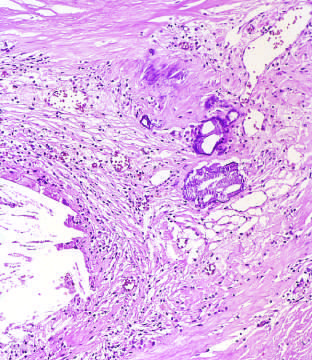did the high-power view of the junction of the fibrous cap and core show scattered inflammatory cells, calcification arrowheads, and neovascularization?
Answer the question using a single word or phrase. Yes 